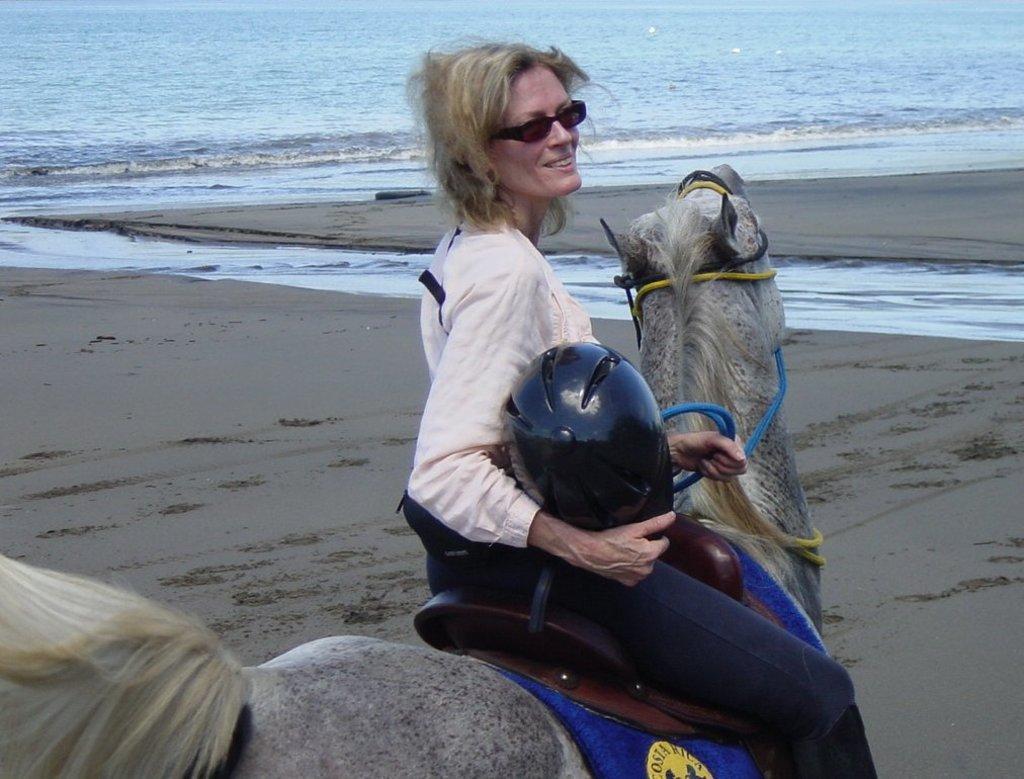Could you give a brief overview of what you see in this image? In this image we can see there is a person sitting on the horse and holding a helmet and thread. And there is sand and water. 